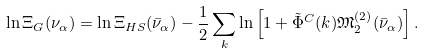Convert formula to latex. <formula><loc_0><loc_0><loc_500><loc_500>\ln \Xi _ { G } ( \nu _ { \alpha } ) = \ln \Xi _ { H S } ( { \bar { \nu } _ { \alpha } } ) - \frac { 1 } { 2 } \sum _ { k } \ln \left [ 1 + \tilde { \Phi } ^ { C } ( k ) { \mathfrak { M } } _ { 2 } ^ { ( 2 ) } ( { \bar { \nu } _ { \alpha } } ) \right ] .</formula> 